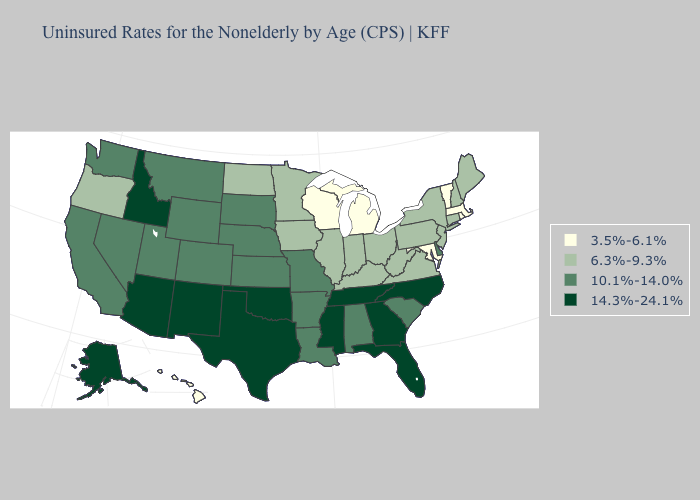What is the value of Maryland?
Answer briefly. 3.5%-6.1%. Among the states that border New Hampshire , which have the lowest value?
Give a very brief answer. Massachusetts, Vermont. What is the highest value in the Northeast ?
Keep it brief. 6.3%-9.3%. Among the states that border Connecticut , does Rhode Island have the highest value?
Be succinct. No. What is the highest value in the West ?
Be succinct. 14.3%-24.1%. Name the states that have a value in the range 10.1%-14.0%?
Concise answer only. Alabama, Arkansas, California, Colorado, Delaware, Kansas, Louisiana, Missouri, Montana, Nebraska, Nevada, South Carolina, South Dakota, Utah, Washington, Wyoming. What is the lowest value in states that border Indiana?
Write a very short answer. 3.5%-6.1%. Name the states that have a value in the range 10.1%-14.0%?
Quick response, please. Alabama, Arkansas, California, Colorado, Delaware, Kansas, Louisiana, Missouri, Montana, Nebraska, Nevada, South Carolina, South Dakota, Utah, Washington, Wyoming. Does Washington have the lowest value in the USA?
Concise answer only. No. Does Indiana have a lower value than Idaho?
Give a very brief answer. Yes. Does the first symbol in the legend represent the smallest category?
Be succinct. Yes. Among the states that border Pennsylvania , does West Virginia have the highest value?
Short answer required. No. What is the value of West Virginia?
Answer briefly. 6.3%-9.3%. Name the states that have a value in the range 6.3%-9.3%?
Keep it brief. Connecticut, Illinois, Indiana, Iowa, Kentucky, Maine, Minnesota, New Hampshire, New Jersey, New York, North Dakota, Ohio, Oregon, Pennsylvania, Virginia, West Virginia. Does Wisconsin have a lower value than Michigan?
Short answer required. No. 